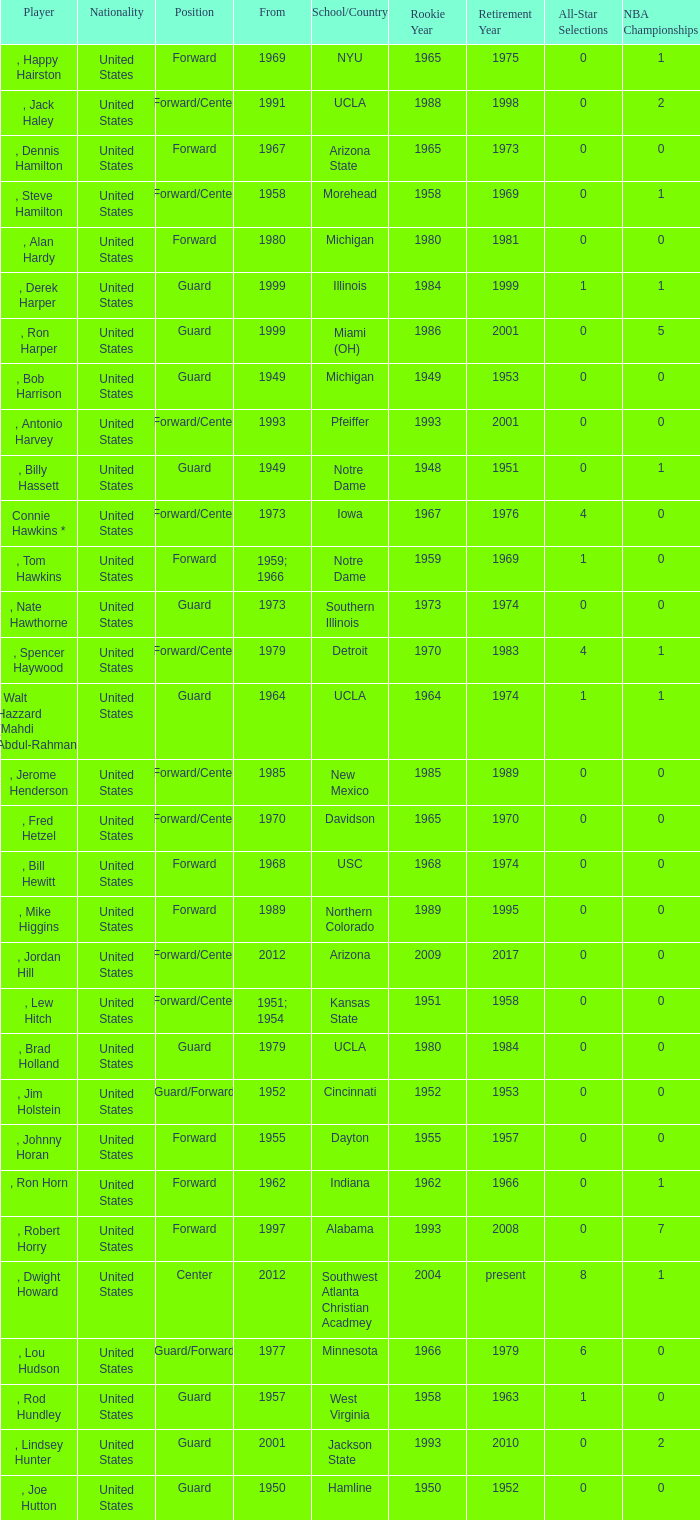What position was for Arizona State? Forward. 